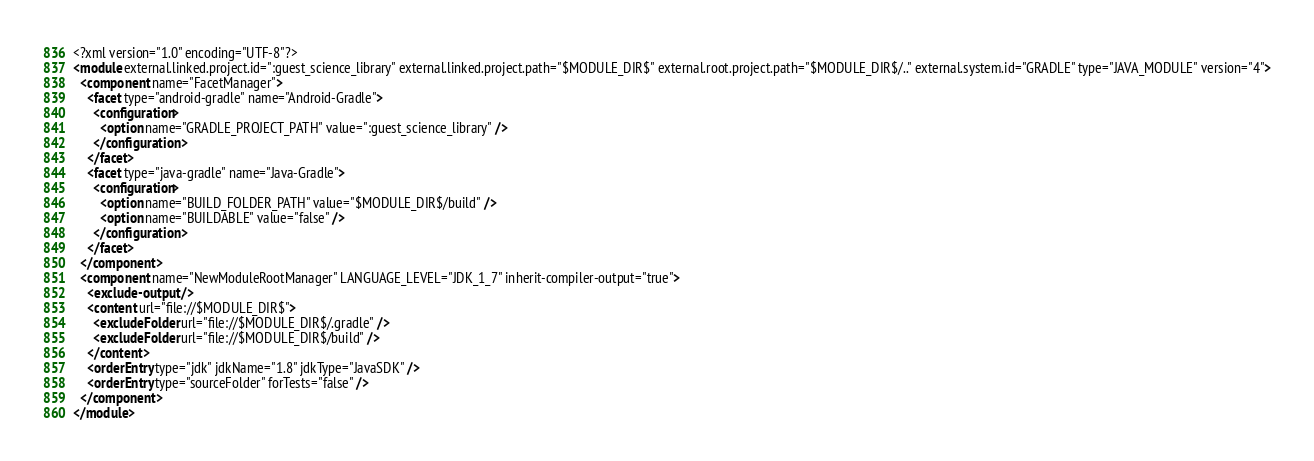<code> <loc_0><loc_0><loc_500><loc_500><_XML_><?xml version="1.0" encoding="UTF-8"?>
<module external.linked.project.id=":guest_science_library" external.linked.project.path="$MODULE_DIR$" external.root.project.path="$MODULE_DIR$/.." external.system.id="GRADLE" type="JAVA_MODULE" version="4">
  <component name="FacetManager">
    <facet type="android-gradle" name="Android-Gradle">
      <configuration>
        <option name="GRADLE_PROJECT_PATH" value=":guest_science_library" />
      </configuration>
    </facet>
    <facet type="java-gradle" name="Java-Gradle">
      <configuration>
        <option name="BUILD_FOLDER_PATH" value="$MODULE_DIR$/build" />
        <option name="BUILDABLE" value="false" />
      </configuration>
    </facet>
  </component>
  <component name="NewModuleRootManager" LANGUAGE_LEVEL="JDK_1_7" inherit-compiler-output="true">
    <exclude-output />
    <content url="file://$MODULE_DIR$">
      <excludeFolder url="file://$MODULE_DIR$/.gradle" />
      <excludeFolder url="file://$MODULE_DIR$/build" />
    </content>
    <orderEntry type="jdk" jdkName="1.8" jdkType="JavaSDK" />
    <orderEntry type="sourceFolder" forTests="false" />
  </component>
</module></code> 